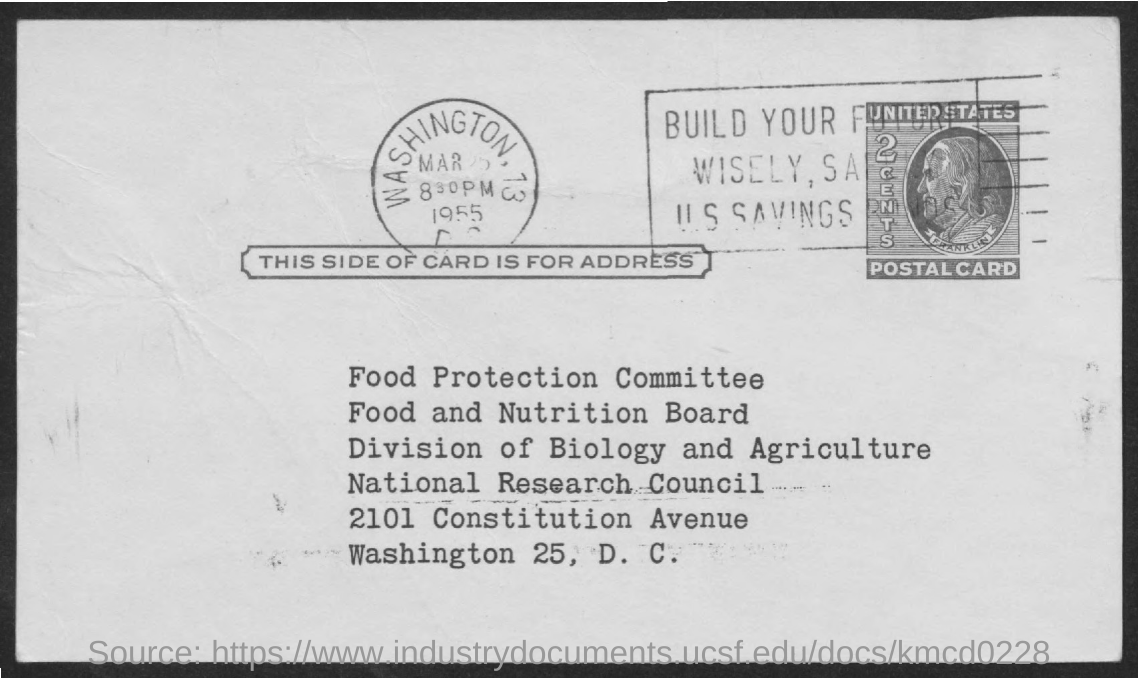What is the name of the committee
Provide a short and direct response. Food Protection Committee. What is the year mentioned on the stamp
Offer a very short reply. 1955. What is the division mentioned in the given form ?
Provide a succinct answer. Division of biology and agriculture. Which city name is mentioned in the address
Provide a short and direct response. Washington 25 , D.C. Which country name is mentioned on the postal stamp
Offer a terse response. United States. 